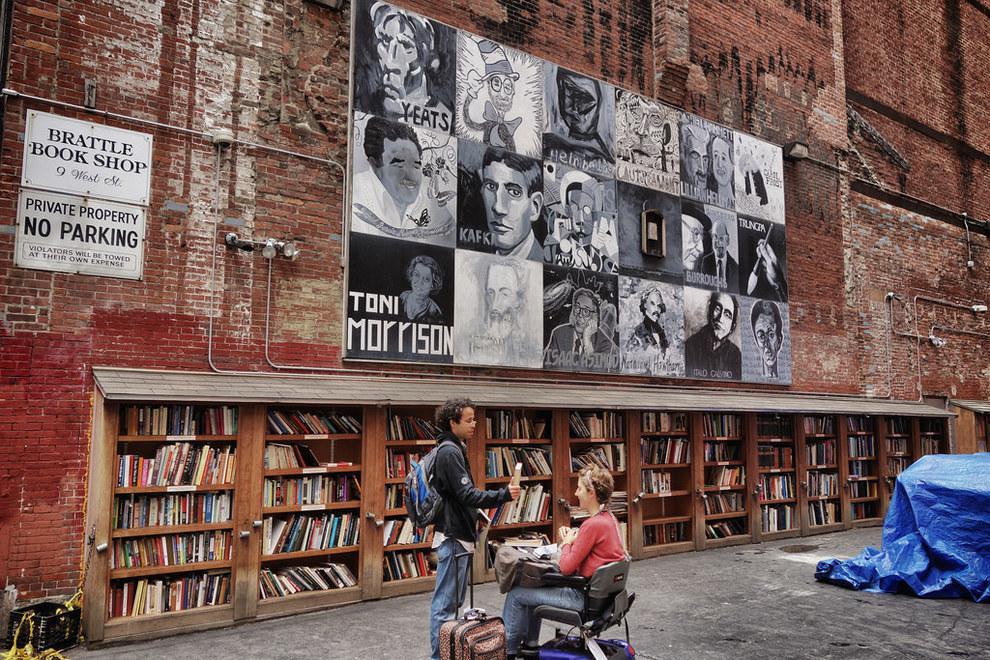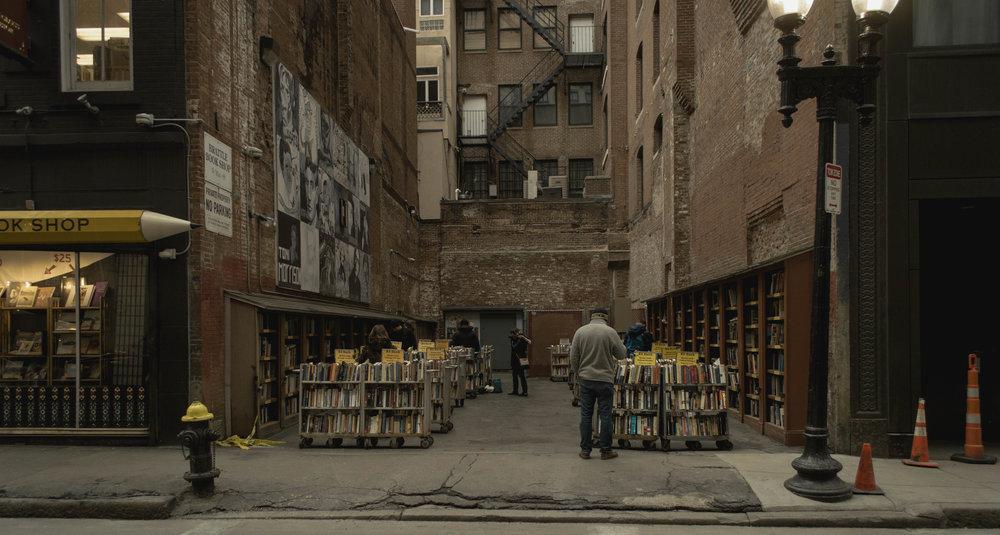The first image is the image on the left, the second image is the image on the right. Considering the images on both sides, is "Both are exterior views, but only the right image shows a yellow pencil shape pointing toward an area between brick buildings where wheeled carts of books are topped with yellow signs." valid? Answer yes or no. Yes. The first image is the image on the left, the second image is the image on the right. Examine the images to the left and right. Is the description "People are looking at books in an alley in the image on the right." accurate? Answer yes or no. Yes. 